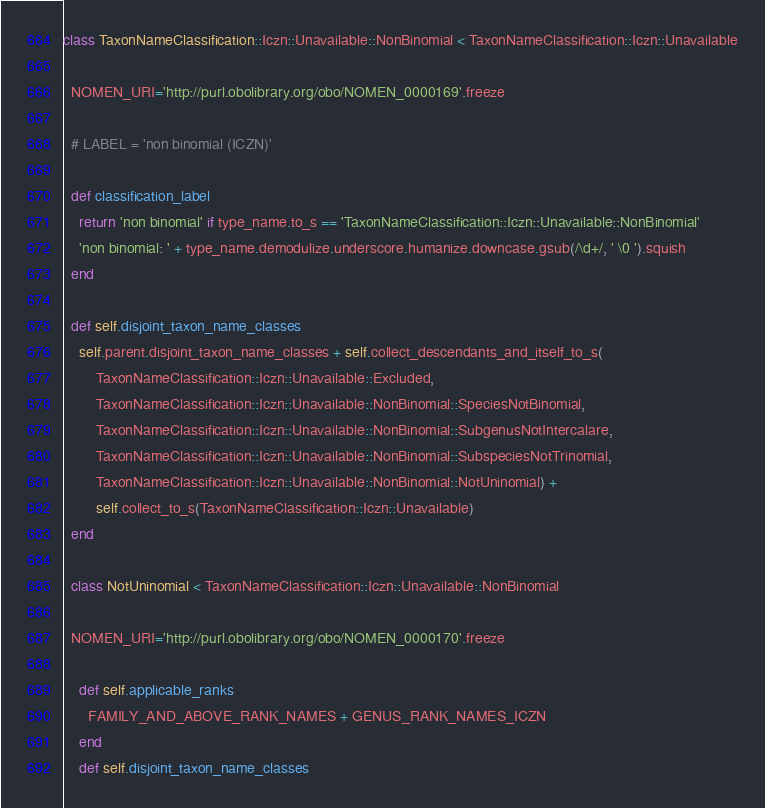<code> <loc_0><loc_0><loc_500><loc_500><_Ruby_>class TaxonNameClassification::Iczn::Unavailable::NonBinomial < TaxonNameClassification::Iczn::Unavailable

  NOMEN_URI='http://purl.obolibrary.org/obo/NOMEN_0000169'.freeze

  # LABEL = 'non binomial (ICZN)'

  def classification_label
    return 'non binomial' if type_name.to_s == 'TaxonNameClassification::Iczn::Unavailable::NonBinomial'
    'non binomial: ' + type_name.demodulize.underscore.humanize.downcase.gsub(/\d+/, ' \0 ').squish
  end

  def self.disjoint_taxon_name_classes
    self.parent.disjoint_taxon_name_classes + self.collect_descendants_and_itself_to_s(
        TaxonNameClassification::Iczn::Unavailable::Excluded,
        TaxonNameClassification::Iczn::Unavailable::NonBinomial::SpeciesNotBinomial,
        TaxonNameClassification::Iczn::Unavailable::NonBinomial::SubgenusNotIntercalare,
        TaxonNameClassification::Iczn::Unavailable::NonBinomial::SubspeciesNotTrinomial,
        TaxonNameClassification::Iczn::Unavailable::NonBinomial::NotUninomial) +
        self.collect_to_s(TaxonNameClassification::Iczn::Unavailable)
  end

  class NotUninomial < TaxonNameClassification::Iczn::Unavailable::NonBinomial

  NOMEN_URI='http://purl.obolibrary.org/obo/NOMEN_0000170'.freeze

    def self.applicable_ranks
      FAMILY_AND_ABOVE_RANK_NAMES + GENUS_RANK_NAMES_ICZN
    end
    def self.disjoint_taxon_name_classes</code> 